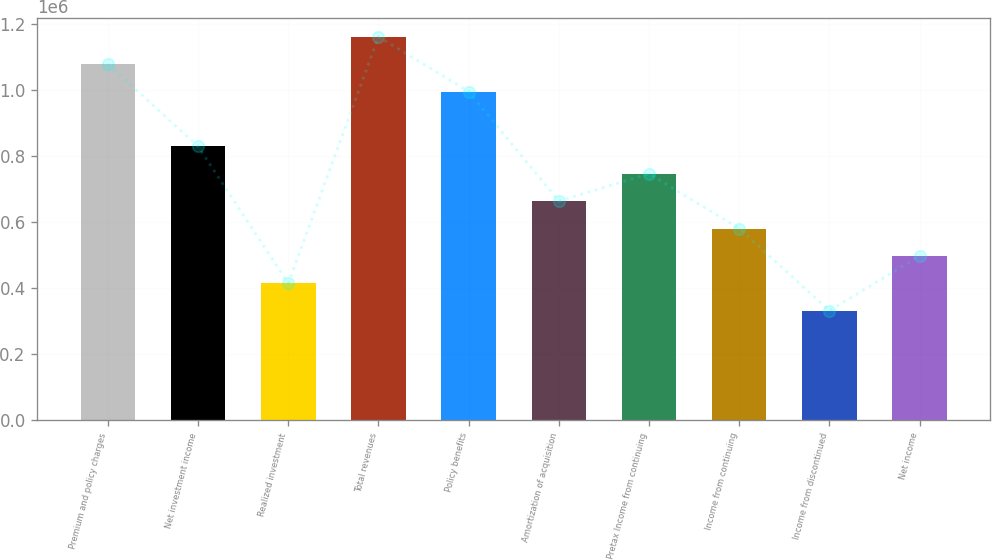<chart> <loc_0><loc_0><loc_500><loc_500><bar_chart><fcel>Premium and policy charges<fcel>Net investment income<fcel>Realized investment<fcel>Total revenues<fcel>Policy benefits<fcel>Amortization of acquisition<fcel>Pretax Income from continuing<fcel>Income from continuing<fcel>Income from discontinued<fcel>Net income<nl><fcel>1.07805e+06<fcel>829272<fcel>414636<fcel>1.16098e+06<fcel>995126<fcel>663418<fcel>746345<fcel>580490<fcel>331709<fcel>497563<nl></chart> 